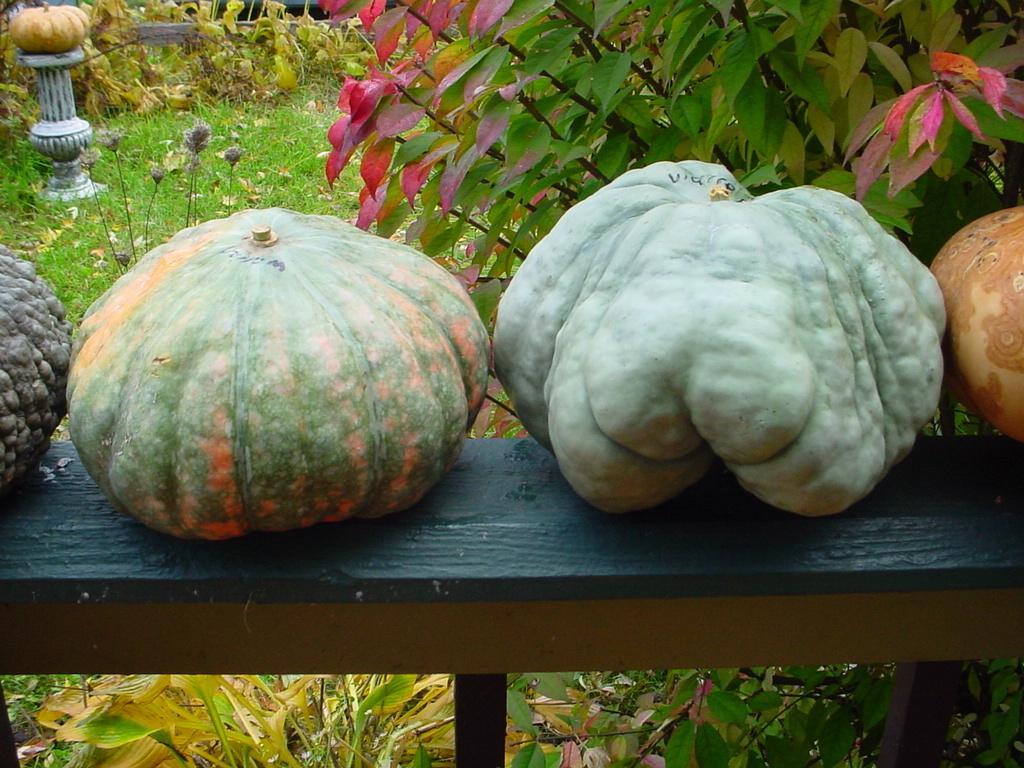How would you summarize this image in a sentence or two? In the image there are different types of gourds kept on a bench and around them there is grass and plants. 